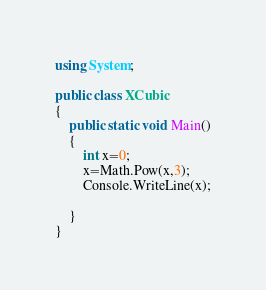Convert code to text. <code><loc_0><loc_0><loc_500><loc_500><_C#_>using System;

public class XCubic
{
	public static void Main()
	{
		int x=0;
		x=Math.Pow(x,3);
		Console.WriteLine(x);
		
	}
}</code> 